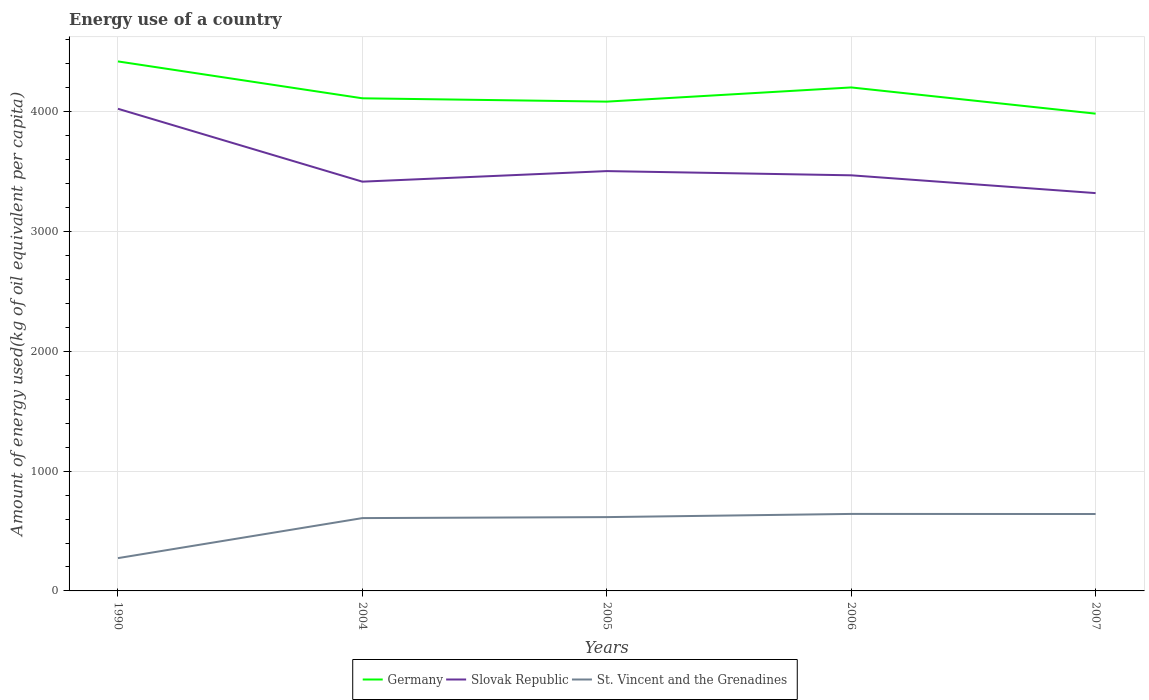How many different coloured lines are there?
Provide a succinct answer. 3. Across all years, what is the maximum amount of energy used in in St. Vincent and the Grenadines?
Make the answer very short. 273.78. In which year was the amount of energy used in in St. Vincent and the Grenadines maximum?
Offer a terse response. 1990. What is the total amount of energy used in in St. Vincent and the Grenadines in the graph?
Provide a short and direct response. -368.96. What is the difference between the highest and the second highest amount of energy used in in Slovak Republic?
Your answer should be very brief. 703.91. What is the difference between the highest and the lowest amount of energy used in in Germany?
Offer a terse response. 2. Is the amount of energy used in in Slovak Republic strictly greater than the amount of energy used in in Germany over the years?
Offer a terse response. Yes. How many years are there in the graph?
Your answer should be very brief. 5. Are the values on the major ticks of Y-axis written in scientific E-notation?
Ensure brevity in your answer.  No. How many legend labels are there?
Make the answer very short. 3. What is the title of the graph?
Keep it short and to the point. Energy use of a country. What is the label or title of the X-axis?
Your answer should be very brief. Years. What is the label or title of the Y-axis?
Make the answer very short. Amount of energy used(kg of oil equivalent per capita). What is the Amount of energy used(kg of oil equivalent per capita) in Germany in 1990?
Offer a very short reply. 4420.01. What is the Amount of energy used(kg of oil equivalent per capita) of Slovak Republic in 1990?
Your answer should be compact. 4024.67. What is the Amount of energy used(kg of oil equivalent per capita) in St. Vincent and the Grenadines in 1990?
Provide a succinct answer. 273.78. What is the Amount of energy used(kg of oil equivalent per capita) in Germany in 2004?
Make the answer very short. 4112.12. What is the Amount of energy used(kg of oil equivalent per capita) of Slovak Republic in 2004?
Provide a short and direct response. 3416.25. What is the Amount of energy used(kg of oil equivalent per capita) of St. Vincent and the Grenadines in 2004?
Offer a very short reply. 607.94. What is the Amount of energy used(kg of oil equivalent per capita) in Germany in 2005?
Offer a terse response. 4084.33. What is the Amount of energy used(kg of oil equivalent per capita) of Slovak Republic in 2005?
Provide a short and direct response. 3504.48. What is the Amount of energy used(kg of oil equivalent per capita) in St. Vincent and the Grenadines in 2005?
Offer a very short reply. 616.1. What is the Amount of energy used(kg of oil equivalent per capita) of Germany in 2006?
Ensure brevity in your answer.  4202.75. What is the Amount of energy used(kg of oil equivalent per capita) of Slovak Republic in 2006?
Offer a very short reply. 3469.29. What is the Amount of energy used(kg of oil equivalent per capita) in St. Vincent and the Grenadines in 2006?
Offer a terse response. 642.74. What is the Amount of energy used(kg of oil equivalent per capita) of Germany in 2007?
Offer a terse response. 3983.88. What is the Amount of energy used(kg of oil equivalent per capita) in Slovak Republic in 2007?
Keep it short and to the point. 3320.76. What is the Amount of energy used(kg of oil equivalent per capita) in St. Vincent and the Grenadines in 2007?
Make the answer very short. 641.91. Across all years, what is the maximum Amount of energy used(kg of oil equivalent per capita) in Germany?
Provide a succinct answer. 4420.01. Across all years, what is the maximum Amount of energy used(kg of oil equivalent per capita) of Slovak Republic?
Keep it short and to the point. 4024.67. Across all years, what is the maximum Amount of energy used(kg of oil equivalent per capita) of St. Vincent and the Grenadines?
Your answer should be very brief. 642.74. Across all years, what is the minimum Amount of energy used(kg of oil equivalent per capita) in Germany?
Keep it short and to the point. 3983.88. Across all years, what is the minimum Amount of energy used(kg of oil equivalent per capita) of Slovak Republic?
Offer a terse response. 3320.76. Across all years, what is the minimum Amount of energy used(kg of oil equivalent per capita) of St. Vincent and the Grenadines?
Ensure brevity in your answer.  273.78. What is the total Amount of energy used(kg of oil equivalent per capita) of Germany in the graph?
Provide a succinct answer. 2.08e+04. What is the total Amount of energy used(kg of oil equivalent per capita) in Slovak Republic in the graph?
Keep it short and to the point. 1.77e+04. What is the total Amount of energy used(kg of oil equivalent per capita) in St. Vincent and the Grenadines in the graph?
Offer a very short reply. 2782.48. What is the difference between the Amount of energy used(kg of oil equivalent per capita) in Germany in 1990 and that in 2004?
Provide a short and direct response. 307.88. What is the difference between the Amount of energy used(kg of oil equivalent per capita) of Slovak Republic in 1990 and that in 2004?
Offer a terse response. 608.42. What is the difference between the Amount of energy used(kg of oil equivalent per capita) in St. Vincent and the Grenadines in 1990 and that in 2004?
Offer a terse response. -334.16. What is the difference between the Amount of energy used(kg of oil equivalent per capita) of Germany in 1990 and that in 2005?
Offer a terse response. 335.68. What is the difference between the Amount of energy used(kg of oil equivalent per capita) of Slovak Republic in 1990 and that in 2005?
Provide a short and direct response. 520.19. What is the difference between the Amount of energy used(kg of oil equivalent per capita) in St. Vincent and the Grenadines in 1990 and that in 2005?
Provide a short and direct response. -342.32. What is the difference between the Amount of energy used(kg of oil equivalent per capita) in Germany in 1990 and that in 2006?
Make the answer very short. 217.26. What is the difference between the Amount of energy used(kg of oil equivalent per capita) in Slovak Republic in 1990 and that in 2006?
Offer a very short reply. 555.38. What is the difference between the Amount of energy used(kg of oil equivalent per capita) of St. Vincent and the Grenadines in 1990 and that in 2006?
Offer a very short reply. -368.96. What is the difference between the Amount of energy used(kg of oil equivalent per capita) of Germany in 1990 and that in 2007?
Provide a short and direct response. 436.13. What is the difference between the Amount of energy used(kg of oil equivalent per capita) in Slovak Republic in 1990 and that in 2007?
Give a very brief answer. 703.91. What is the difference between the Amount of energy used(kg of oil equivalent per capita) of St. Vincent and the Grenadines in 1990 and that in 2007?
Ensure brevity in your answer.  -368.13. What is the difference between the Amount of energy used(kg of oil equivalent per capita) of Germany in 2004 and that in 2005?
Your answer should be very brief. 27.79. What is the difference between the Amount of energy used(kg of oil equivalent per capita) in Slovak Republic in 2004 and that in 2005?
Give a very brief answer. -88.23. What is the difference between the Amount of energy used(kg of oil equivalent per capita) in St. Vincent and the Grenadines in 2004 and that in 2005?
Give a very brief answer. -8.16. What is the difference between the Amount of energy used(kg of oil equivalent per capita) in Germany in 2004 and that in 2006?
Offer a terse response. -90.63. What is the difference between the Amount of energy used(kg of oil equivalent per capita) in Slovak Republic in 2004 and that in 2006?
Keep it short and to the point. -53.04. What is the difference between the Amount of energy used(kg of oil equivalent per capita) in St. Vincent and the Grenadines in 2004 and that in 2006?
Provide a succinct answer. -34.8. What is the difference between the Amount of energy used(kg of oil equivalent per capita) in Germany in 2004 and that in 2007?
Your response must be concise. 128.24. What is the difference between the Amount of energy used(kg of oil equivalent per capita) of Slovak Republic in 2004 and that in 2007?
Provide a short and direct response. 95.49. What is the difference between the Amount of energy used(kg of oil equivalent per capita) in St. Vincent and the Grenadines in 2004 and that in 2007?
Keep it short and to the point. -33.97. What is the difference between the Amount of energy used(kg of oil equivalent per capita) in Germany in 2005 and that in 2006?
Your answer should be compact. -118.42. What is the difference between the Amount of energy used(kg of oil equivalent per capita) of Slovak Republic in 2005 and that in 2006?
Provide a succinct answer. 35.18. What is the difference between the Amount of energy used(kg of oil equivalent per capita) in St. Vincent and the Grenadines in 2005 and that in 2006?
Ensure brevity in your answer.  -26.65. What is the difference between the Amount of energy used(kg of oil equivalent per capita) of Germany in 2005 and that in 2007?
Provide a succinct answer. 100.45. What is the difference between the Amount of energy used(kg of oil equivalent per capita) in Slovak Republic in 2005 and that in 2007?
Give a very brief answer. 183.72. What is the difference between the Amount of energy used(kg of oil equivalent per capita) in St. Vincent and the Grenadines in 2005 and that in 2007?
Your answer should be very brief. -25.82. What is the difference between the Amount of energy used(kg of oil equivalent per capita) in Germany in 2006 and that in 2007?
Your answer should be compact. 218.87. What is the difference between the Amount of energy used(kg of oil equivalent per capita) of Slovak Republic in 2006 and that in 2007?
Your response must be concise. 148.53. What is the difference between the Amount of energy used(kg of oil equivalent per capita) in St. Vincent and the Grenadines in 2006 and that in 2007?
Your response must be concise. 0.83. What is the difference between the Amount of energy used(kg of oil equivalent per capita) of Germany in 1990 and the Amount of energy used(kg of oil equivalent per capita) of Slovak Republic in 2004?
Your answer should be very brief. 1003.76. What is the difference between the Amount of energy used(kg of oil equivalent per capita) of Germany in 1990 and the Amount of energy used(kg of oil equivalent per capita) of St. Vincent and the Grenadines in 2004?
Your answer should be very brief. 3812.07. What is the difference between the Amount of energy used(kg of oil equivalent per capita) in Slovak Republic in 1990 and the Amount of energy used(kg of oil equivalent per capita) in St. Vincent and the Grenadines in 2004?
Offer a terse response. 3416.73. What is the difference between the Amount of energy used(kg of oil equivalent per capita) of Germany in 1990 and the Amount of energy used(kg of oil equivalent per capita) of Slovak Republic in 2005?
Your answer should be very brief. 915.53. What is the difference between the Amount of energy used(kg of oil equivalent per capita) in Germany in 1990 and the Amount of energy used(kg of oil equivalent per capita) in St. Vincent and the Grenadines in 2005?
Provide a short and direct response. 3803.91. What is the difference between the Amount of energy used(kg of oil equivalent per capita) of Slovak Republic in 1990 and the Amount of energy used(kg of oil equivalent per capita) of St. Vincent and the Grenadines in 2005?
Offer a terse response. 3408.57. What is the difference between the Amount of energy used(kg of oil equivalent per capita) of Germany in 1990 and the Amount of energy used(kg of oil equivalent per capita) of Slovak Republic in 2006?
Provide a short and direct response. 950.72. What is the difference between the Amount of energy used(kg of oil equivalent per capita) in Germany in 1990 and the Amount of energy used(kg of oil equivalent per capita) in St. Vincent and the Grenadines in 2006?
Your answer should be very brief. 3777.26. What is the difference between the Amount of energy used(kg of oil equivalent per capita) of Slovak Republic in 1990 and the Amount of energy used(kg of oil equivalent per capita) of St. Vincent and the Grenadines in 2006?
Your answer should be very brief. 3381.92. What is the difference between the Amount of energy used(kg of oil equivalent per capita) of Germany in 1990 and the Amount of energy used(kg of oil equivalent per capita) of Slovak Republic in 2007?
Offer a very short reply. 1099.25. What is the difference between the Amount of energy used(kg of oil equivalent per capita) in Germany in 1990 and the Amount of energy used(kg of oil equivalent per capita) in St. Vincent and the Grenadines in 2007?
Provide a short and direct response. 3778.09. What is the difference between the Amount of energy used(kg of oil equivalent per capita) of Slovak Republic in 1990 and the Amount of energy used(kg of oil equivalent per capita) of St. Vincent and the Grenadines in 2007?
Make the answer very short. 3382.76. What is the difference between the Amount of energy used(kg of oil equivalent per capita) in Germany in 2004 and the Amount of energy used(kg of oil equivalent per capita) in Slovak Republic in 2005?
Your answer should be compact. 607.65. What is the difference between the Amount of energy used(kg of oil equivalent per capita) of Germany in 2004 and the Amount of energy used(kg of oil equivalent per capita) of St. Vincent and the Grenadines in 2005?
Offer a terse response. 3496.03. What is the difference between the Amount of energy used(kg of oil equivalent per capita) of Slovak Republic in 2004 and the Amount of energy used(kg of oil equivalent per capita) of St. Vincent and the Grenadines in 2005?
Provide a succinct answer. 2800.15. What is the difference between the Amount of energy used(kg of oil equivalent per capita) of Germany in 2004 and the Amount of energy used(kg of oil equivalent per capita) of Slovak Republic in 2006?
Provide a short and direct response. 642.83. What is the difference between the Amount of energy used(kg of oil equivalent per capita) in Germany in 2004 and the Amount of energy used(kg of oil equivalent per capita) in St. Vincent and the Grenadines in 2006?
Ensure brevity in your answer.  3469.38. What is the difference between the Amount of energy used(kg of oil equivalent per capita) in Slovak Republic in 2004 and the Amount of energy used(kg of oil equivalent per capita) in St. Vincent and the Grenadines in 2006?
Make the answer very short. 2773.5. What is the difference between the Amount of energy used(kg of oil equivalent per capita) in Germany in 2004 and the Amount of energy used(kg of oil equivalent per capita) in Slovak Republic in 2007?
Your response must be concise. 791.36. What is the difference between the Amount of energy used(kg of oil equivalent per capita) in Germany in 2004 and the Amount of energy used(kg of oil equivalent per capita) in St. Vincent and the Grenadines in 2007?
Provide a short and direct response. 3470.21. What is the difference between the Amount of energy used(kg of oil equivalent per capita) of Slovak Republic in 2004 and the Amount of energy used(kg of oil equivalent per capita) of St. Vincent and the Grenadines in 2007?
Ensure brevity in your answer.  2774.33. What is the difference between the Amount of energy used(kg of oil equivalent per capita) in Germany in 2005 and the Amount of energy used(kg of oil equivalent per capita) in Slovak Republic in 2006?
Offer a very short reply. 615.04. What is the difference between the Amount of energy used(kg of oil equivalent per capita) of Germany in 2005 and the Amount of energy used(kg of oil equivalent per capita) of St. Vincent and the Grenadines in 2006?
Keep it short and to the point. 3441.59. What is the difference between the Amount of energy used(kg of oil equivalent per capita) of Slovak Republic in 2005 and the Amount of energy used(kg of oil equivalent per capita) of St. Vincent and the Grenadines in 2006?
Provide a succinct answer. 2861.73. What is the difference between the Amount of energy used(kg of oil equivalent per capita) in Germany in 2005 and the Amount of energy used(kg of oil equivalent per capita) in Slovak Republic in 2007?
Offer a terse response. 763.57. What is the difference between the Amount of energy used(kg of oil equivalent per capita) in Germany in 2005 and the Amount of energy used(kg of oil equivalent per capita) in St. Vincent and the Grenadines in 2007?
Your response must be concise. 3442.42. What is the difference between the Amount of energy used(kg of oil equivalent per capita) of Slovak Republic in 2005 and the Amount of energy used(kg of oil equivalent per capita) of St. Vincent and the Grenadines in 2007?
Your answer should be compact. 2862.56. What is the difference between the Amount of energy used(kg of oil equivalent per capita) in Germany in 2006 and the Amount of energy used(kg of oil equivalent per capita) in Slovak Republic in 2007?
Your response must be concise. 881.99. What is the difference between the Amount of energy used(kg of oil equivalent per capita) in Germany in 2006 and the Amount of energy used(kg of oil equivalent per capita) in St. Vincent and the Grenadines in 2007?
Provide a short and direct response. 3560.84. What is the difference between the Amount of energy used(kg of oil equivalent per capita) in Slovak Republic in 2006 and the Amount of energy used(kg of oil equivalent per capita) in St. Vincent and the Grenadines in 2007?
Provide a succinct answer. 2827.38. What is the average Amount of energy used(kg of oil equivalent per capita) in Germany per year?
Keep it short and to the point. 4160.62. What is the average Amount of energy used(kg of oil equivalent per capita) of Slovak Republic per year?
Offer a very short reply. 3547.09. What is the average Amount of energy used(kg of oil equivalent per capita) of St. Vincent and the Grenadines per year?
Your answer should be very brief. 556.5. In the year 1990, what is the difference between the Amount of energy used(kg of oil equivalent per capita) of Germany and Amount of energy used(kg of oil equivalent per capita) of Slovak Republic?
Offer a terse response. 395.34. In the year 1990, what is the difference between the Amount of energy used(kg of oil equivalent per capita) of Germany and Amount of energy used(kg of oil equivalent per capita) of St. Vincent and the Grenadines?
Offer a very short reply. 4146.23. In the year 1990, what is the difference between the Amount of energy used(kg of oil equivalent per capita) of Slovak Republic and Amount of energy used(kg of oil equivalent per capita) of St. Vincent and the Grenadines?
Make the answer very short. 3750.89. In the year 2004, what is the difference between the Amount of energy used(kg of oil equivalent per capita) of Germany and Amount of energy used(kg of oil equivalent per capita) of Slovak Republic?
Give a very brief answer. 695.88. In the year 2004, what is the difference between the Amount of energy used(kg of oil equivalent per capita) in Germany and Amount of energy used(kg of oil equivalent per capita) in St. Vincent and the Grenadines?
Make the answer very short. 3504.18. In the year 2004, what is the difference between the Amount of energy used(kg of oil equivalent per capita) in Slovak Republic and Amount of energy used(kg of oil equivalent per capita) in St. Vincent and the Grenadines?
Your response must be concise. 2808.31. In the year 2005, what is the difference between the Amount of energy used(kg of oil equivalent per capita) in Germany and Amount of energy used(kg of oil equivalent per capita) in Slovak Republic?
Make the answer very short. 579.86. In the year 2005, what is the difference between the Amount of energy used(kg of oil equivalent per capita) of Germany and Amount of energy used(kg of oil equivalent per capita) of St. Vincent and the Grenadines?
Offer a terse response. 3468.23. In the year 2005, what is the difference between the Amount of energy used(kg of oil equivalent per capita) of Slovak Republic and Amount of energy used(kg of oil equivalent per capita) of St. Vincent and the Grenadines?
Give a very brief answer. 2888.38. In the year 2006, what is the difference between the Amount of energy used(kg of oil equivalent per capita) of Germany and Amount of energy used(kg of oil equivalent per capita) of Slovak Republic?
Keep it short and to the point. 733.46. In the year 2006, what is the difference between the Amount of energy used(kg of oil equivalent per capita) of Germany and Amount of energy used(kg of oil equivalent per capita) of St. Vincent and the Grenadines?
Give a very brief answer. 3560.01. In the year 2006, what is the difference between the Amount of energy used(kg of oil equivalent per capita) in Slovak Republic and Amount of energy used(kg of oil equivalent per capita) in St. Vincent and the Grenadines?
Keep it short and to the point. 2826.55. In the year 2007, what is the difference between the Amount of energy used(kg of oil equivalent per capita) of Germany and Amount of energy used(kg of oil equivalent per capita) of Slovak Republic?
Your answer should be compact. 663.12. In the year 2007, what is the difference between the Amount of energy used(kg of oil equivalent per capita) in Germany and Amount of energy used(kg of oil equivalent per capita) in St. Vincent and the Grenadines?
Provide a short and direct response. 3341.97. In the year 2007, what is the difference between the Amount of energy used(kg of oil equivalent per capita) of Slovak Republic and Amount of energy used(kg of oil equivalent per capita) of St. Vincent and the Grenadines?
Provide a short and direct response. 2678.85. What is the ratio of the Amount of energy used(kg of oil equivalent per capita) of Germany in 1990 to that in 2004?
Your answer should be very brief. 1.07. What is the ratio of the Amount of energy used(kg of oil equivalent per capita) of Slovak Republic in 1990 to that in 2004?
Offer a very short reply. 1.18. What is the ratio of the Amount of energy used(kg of oil equivalent per capita) of St. Vincent and the Grenadines in 1990 to that in 2004?
Your answer should be very brief. 0.45. What is the ratio of the Amount of energy used(kg of oil equivalent per capita) in Germany in 1990 to that in 2005?
Your answer should be compact. 1.08. What is the ratio of the Amount of energy used(kg of oil equivalent per capita) of Slovak Republic in 1990 to that in 2005?
Your answer should be compact. 1.15. What is the ratio of the Amount of energy used(kg of oil equivalent per capita) in St. Vincent and the Grenadines in 1990 to that in 2005?
Offer a very short reply. 0.44. What is the ratio of the Amount of energy used(kg of oil equivalent per capita) of Germany in 1990 to that in 2006?
Your answer should be very brief. 1.05. What is the ratio of the Amount of energy used(kg of oil equivalent per capita) of Slovak Republic in 1990 to that in 2006?
Provide a short and direct response. 1.16. What is the ratio of the Amount of energy used(kg of oil equivalent per capita) in St. Vincent and the Grenadines in 1990 to that in 2006?
Provide a short and direct response. 0.43. What is the ratio of the Amount of energy used(kg of oil equivalent per capita) of Germany in 1990 to that in 2007?
Your response must be concise. 1.11. What is the ratio of the Amount of energy used(kg of oil equivalent per capita) of Slovak Republic in 1990 to that in 2007?
Your answer should be very brief. 1.21. What is the ratio of the Amount of energy used(kg of oil equivalent per capita) of St. Vincent and the Grenadines in 1990 to that in 2007?
Offer a terse response. 0.43. What is the ratio of the Amount of energy used(kg of oil equivalent per capita) of Germany in 2004 to that in 2005?
Make the answer very short. 1.01. What is the ratio of the Amount of energy used(kg of oil equivalent per capita) in Slovak Republic in 2004 to that in 2005?
Offer a very short reply. 0.97. What is the ratio of the Amount of energy used(kg of oil equivalent per capita) of Germany in 2004 to that in 2006?
Make the answer very short. 0.98. What is the ratio of the Amount of energy used(kg of oil equivalent per capita) in Slovak Republic in 2004 to that in 2006?
Provide a short and direct response. 0.98. What is the ratio of the Amount of energy used(kg of oil equivalent per capita) of St. Vincent and the Grenadines in 2004 to that in 2006?
Make the answer very short. 0.95. What is the ratio of the Amount of energy used(kg of oil equivalent per capita) of Germany in 2004 to that in 2007?
Offer a very short reply. 1.03. What is the ratio of the Amount of energy used(kg of oil equivalent per capita) in Slovak Republic in 2004 to that in 2007?
Keep it short and to the point. 1.03. What is the ratio of the Amount of energy used(kg of oil equivalent per capita) of St. Vincent and the Grenadines in 2004 to that in 2007?
Provide a succinct answer. 0.95. What is the ratio of the Amount of energy used(kg of oil equivalent per capita) of Germany in 2005 to that in 2006?
Your answer should be compact. 0.97. What is the ratio of the Amount of energy used(kg of oil equivalent per capita) of St. Vincent and the Grenadines in 2005 to that in 2006?
Keep it short and to the point. 0.96. What is the ratio of the Amount of energy used(kg of oil equivalent per capita) in Germany in 2005 to that in 2007?
Your answer should be compact. 1.03. What is the ratio of the Amount of energy used(kg of oil equivalent per capita) in Slovak Republic in 2005 to that in 2007?
Give a very brief answer. 1.06. What is the ratio of the Amount of energy used(kg of oil equivalent per capita) in St. Vincent and the Grenadines in 2005 to that in 2007?
Keep it short and to the point. 0.96. What is the ratio of the Amount of energy used(kg of oil equivalent per capita) in Germany in 2006 to that in 2007?
Give a very brief answer. 1.05. What is the ratio of the Amount of energy used(kg of oil equivalent per capita) of Slovak Republic in 2006 to that in 2007?
Make the answer very short. 1.04. What is the difference between the highest and the second highest Amount of energy used(kg of oil equivalent per capita) of Germany?
Ensure brevity in your answer.  217.26. What is the difference between the highest and the second highest Amount of energy used(kg of oil equivalent per capita) of Slovak Republic?
Provide a short and direct response. 520.19. What is the difference between the highest and the second highest Amount of energy used(kg of oil equivalent per capita) of St. Vincent and the Grenadines?
Make the answer very short. 0.83. What is the difference between the highest and the lowest Amount of energy used(kg of oil equivalent per capita) in Germany?
Your answer should be very brief. 436.13. What is the difference between the highest and the lowest Amount of energy used(kg of oil equivalent per capita) in Slovak Republic?
Ensure brevity in your answer.  703.91. What is the difference between the highest and the lowest Amount of energy used(kg of oil equivalent per capita) of St. Vincent and the Grenadines?
Offer a terse response. 368.96. 